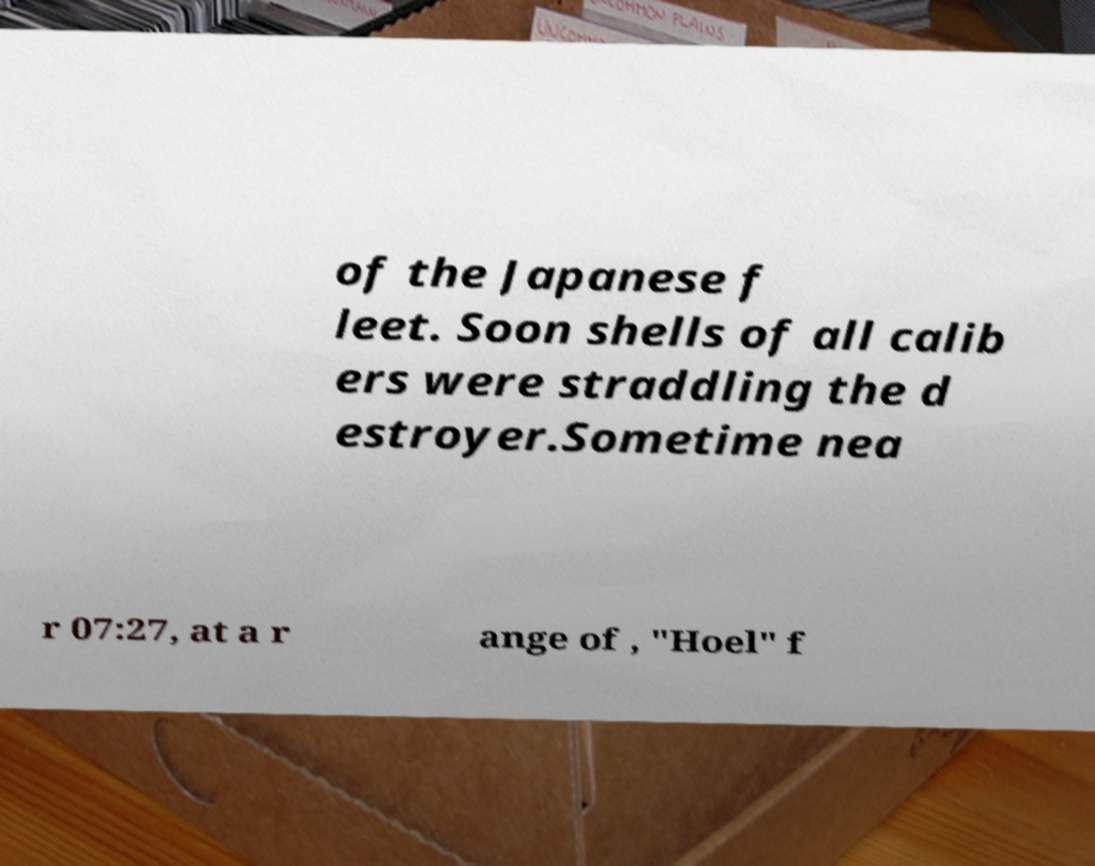Could you assist in decoding the text presented in this image and type it out clearly? of the Japanese f leet. Soon shells of all calib ers were straddling the d estroyer.Sometime nea r 07:27, at a r ange of , "Hoel" f 